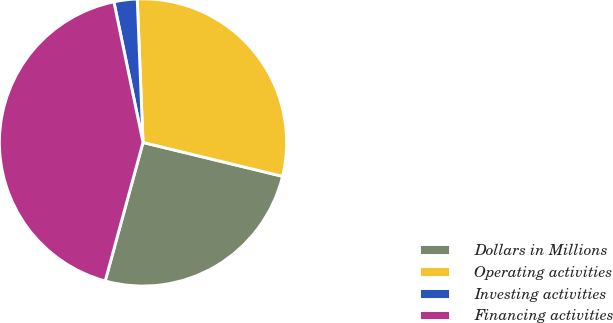<chart> <loc_0><loc_0><loc_500><loc_500><pie_chart><fcel>Dollars in Millions<fcel>Operating activities<fcel>Investing activities<fcel>Financing activities<nl><fcel>25.45%<fcel>29.43%<fcel>2.61%<fcel>42.51%<nl></chart> 